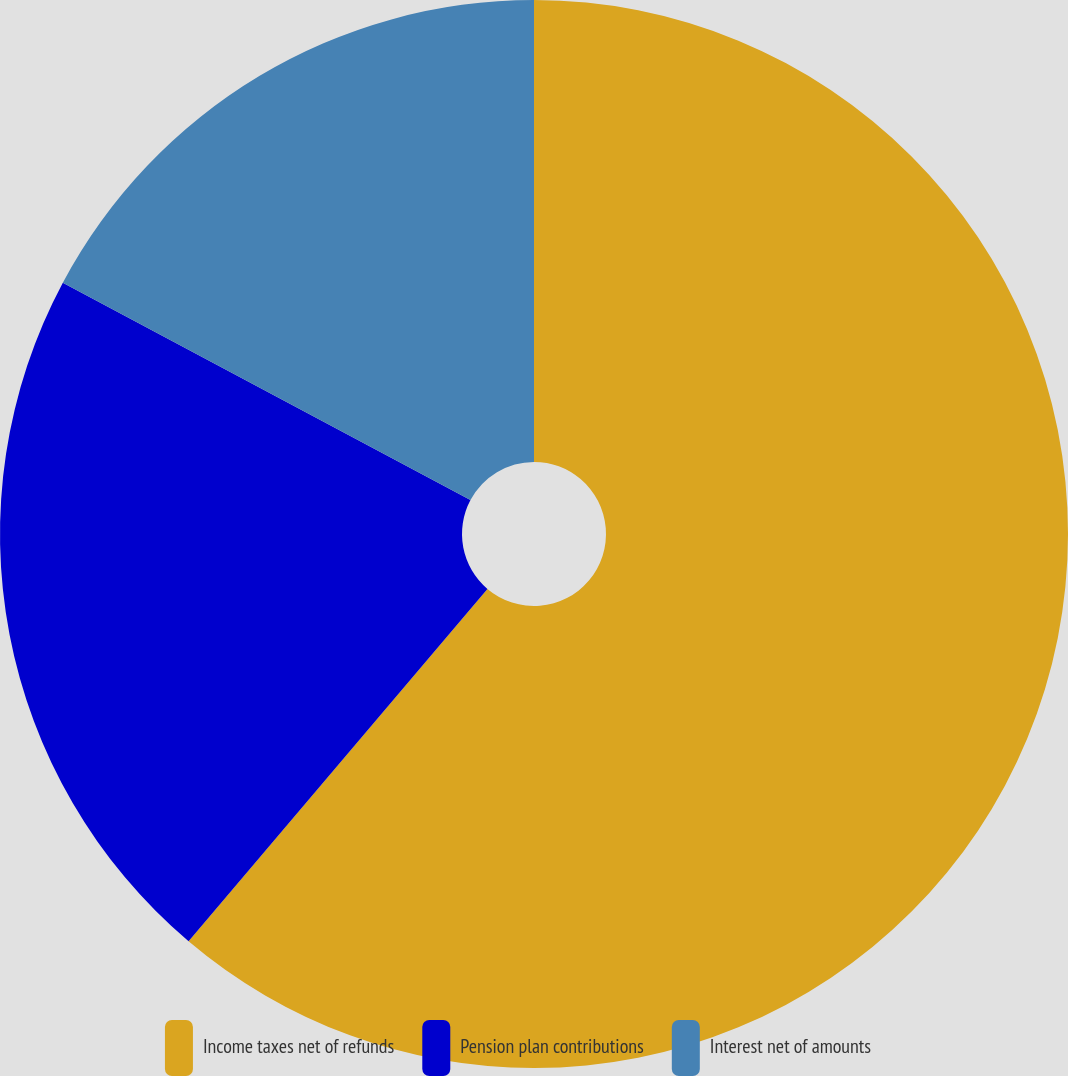Convert chart to OTSL. <chart><loc_0><loc_0><loc_500><loc_500><pie_chart><fcel>Income taxes net of refunds<fcel>Pension plan contributions<fcel>Interest net of amounts<nl><fcel>61.19%<fcel>21.6%<fcel>17.2%<nl></chart> 